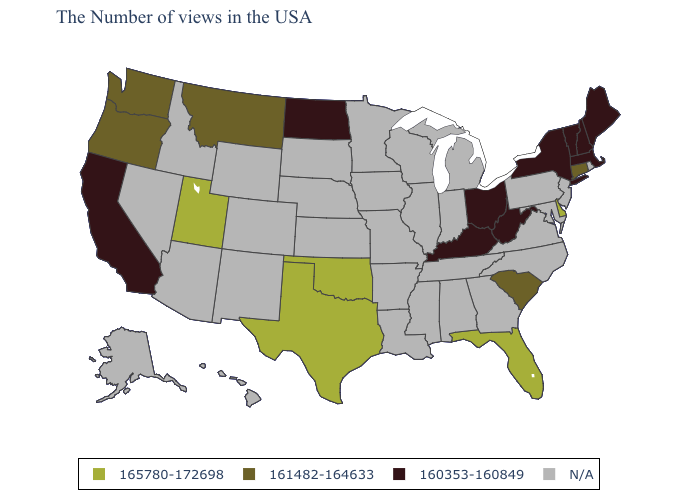What is the value of Florida?
Answer briefly. 165780-172698. Does Delaware have the highest value in the USA?
Write a very short answer. Yes. What is the highest value in states that border Alabama?
Answer briefly. 165780-172698. What is the highest value in the USA?
Answer briefly. 165780-172698. Among the states that border Rhode Island , which have the highest value?
Be succinct. Connecticut. What is the highest value in the South ?
Keep it brief. 165780-172698. What is the value of Minnesota?
Concise answer only. N/A. Name the states that have a value in the range N/A?
Answer briefly. Rhode Island, New Jersey, Maryland, Pennsylvania, Virginia, North Carolina, Georgia, Michigan, Indiana, Alabama, Tennessee, Wisconsin, Illinois, Mississippi, Louisiana, Missouri, Arkansas, Minnesota, Iowa, Kansas, Nebraska, South Dakota, Wyoming, Colorado, New Mexico, Arizona, Idaho, Nevada, Alaska, Hawaii. What is the value of Wisconsin?
Write a very short answer. N/A. What is the highest value in the USA?
Be succinct. 165780-172698. Name the states that have a value in the range 161482-164633?
Quick response, please. Connecticut, South Carolina, Montana, Washington, Oregon. What is the value of Utah?
Quick response, please. 165780-172698. Does the map have missing data?
Be succinct. Yes. 